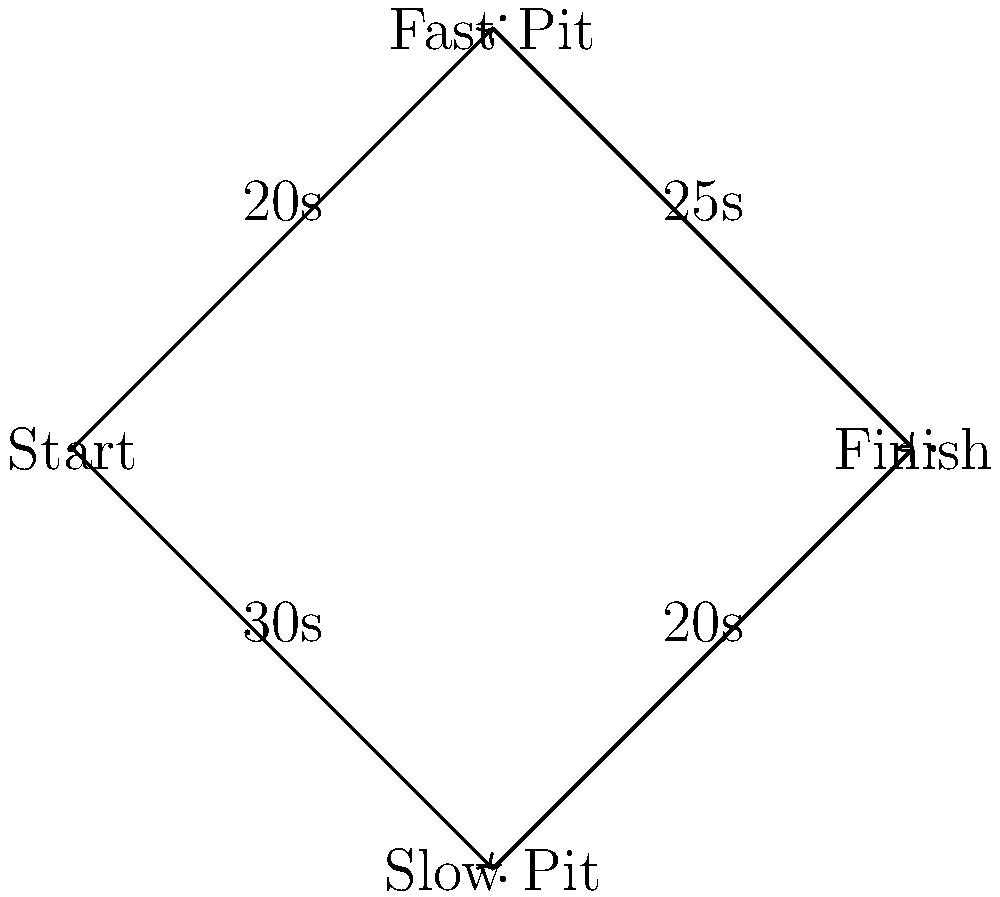As a team owner, you're analyzing pit stop strategies for a crucial race. The network flow diagram represents different pit stop options and their associated times. The "Fast Pit" takes 20 seconds to enter but 25 seconds to exit, while the "Slow Pit" takes 30 seconds to enter but only 20 seconds to exit. What is the optimal pit stop strategy to minimize the total time from Start to Finish? To determine the optimal pit stop strategy, we need to calculate the total time for each possible path from Start to Finish:

1. Path through Fast Pit:
   Start to Fast Pit: 20 seconds
   Fast Pit to Finish: 25 seconds
   Total time: $20 + 25 = 45$ seconds

2. Path through Slow Pit:
   Start to Slow Pit: 30 seconds
   Slow Pit to Finish: 20 seconds
   Total time: $30 + 20 = 50$ seconds

Comparing the two paths:
- Fast Pit path: 45 seconds
- Slow Pit path: 50 seconds

The Fast Pit path is 5 seconds faster than the Slow Pit path.

Therefore, the optimal strategy to minimize the total time from Start to Finish is to choose the Fast Pit option.
Answer: Choose the Fast Pit strategy (45 seconds total). 